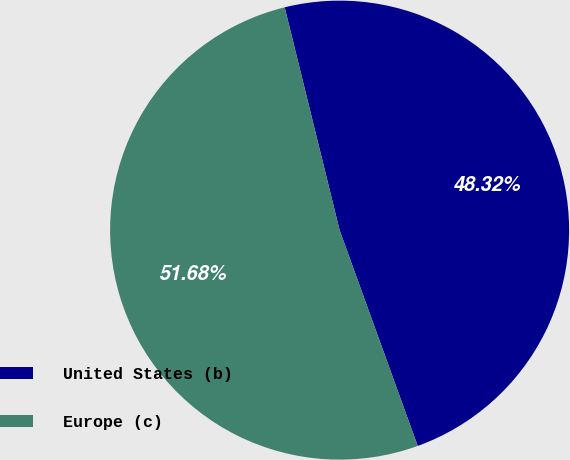Convert chart. <chart><loc_0><loc_0><loc_500><loc_500><pie_chart><fcel>United States (b)<fcel>Europe (c)<nl><fcel>48.32%<fcel>51.68%<nl></chart> 